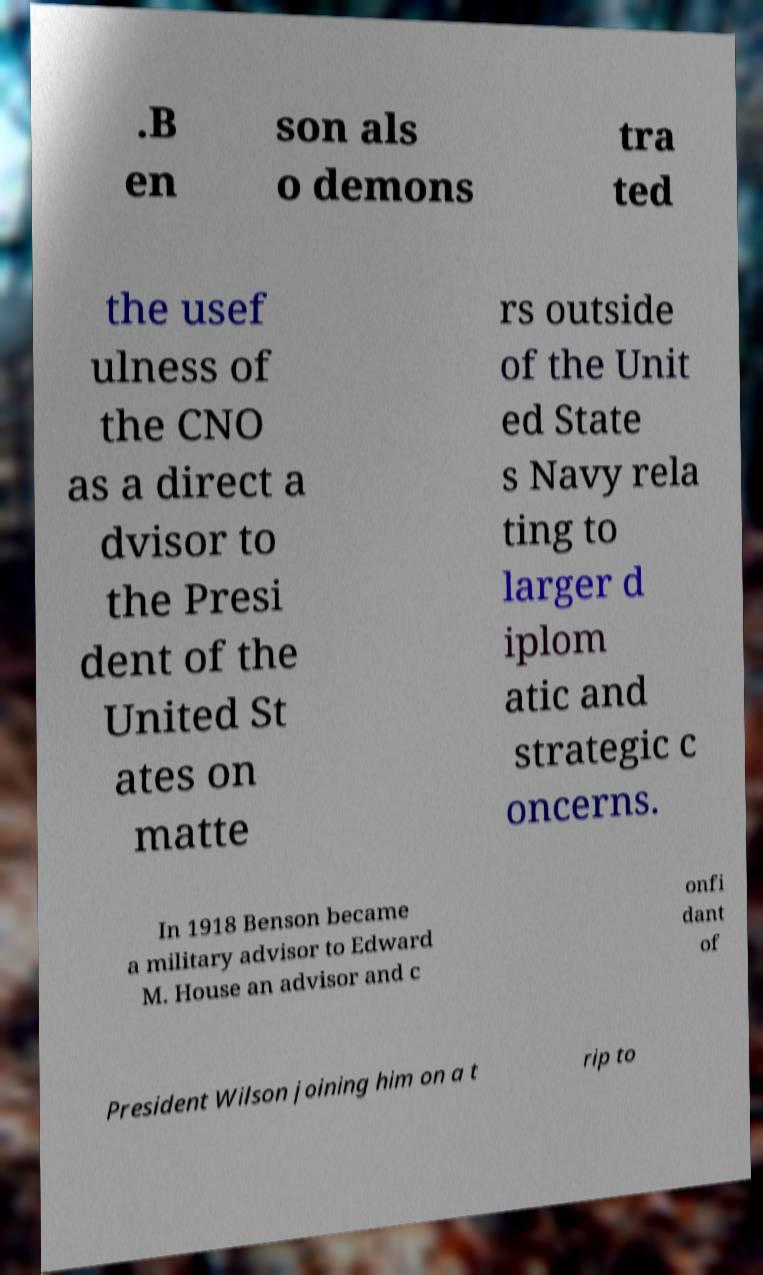Can you read and provide the text displayed in the image?This photo seems to have some interesting text. Can you extract and type it out for me? .B en son als o demons tra ted the usef ulness of the CNO as a direct a dvisor to the Presi dent of the United St ates on matte rs outside of the Unit ed State s Navy rela ting to larger d iplom atic and strategic c oncerns. In 1918 Benson became a military advisor to Edward M. House an advisor and c onfi dant of President Wilson joining him on a t rip to 